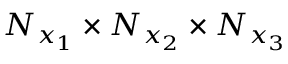Convert formula to latex. <formula><loc_0><loc_0><loc_500><loc_500>N _ { x _ { 1 } } \times N _ { x _ { 2 } } \times N _ { x _ { 3 } }</formula> 